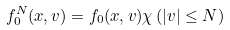Convert formula to latex. <formula><loc_0><loc_0><loc_500><loc_500>f ^ { N } _ { 0 } ( x , v ) = f _ { 0 } ( x , v ) \chi \left ( | v | \leq N \right )</formula> 